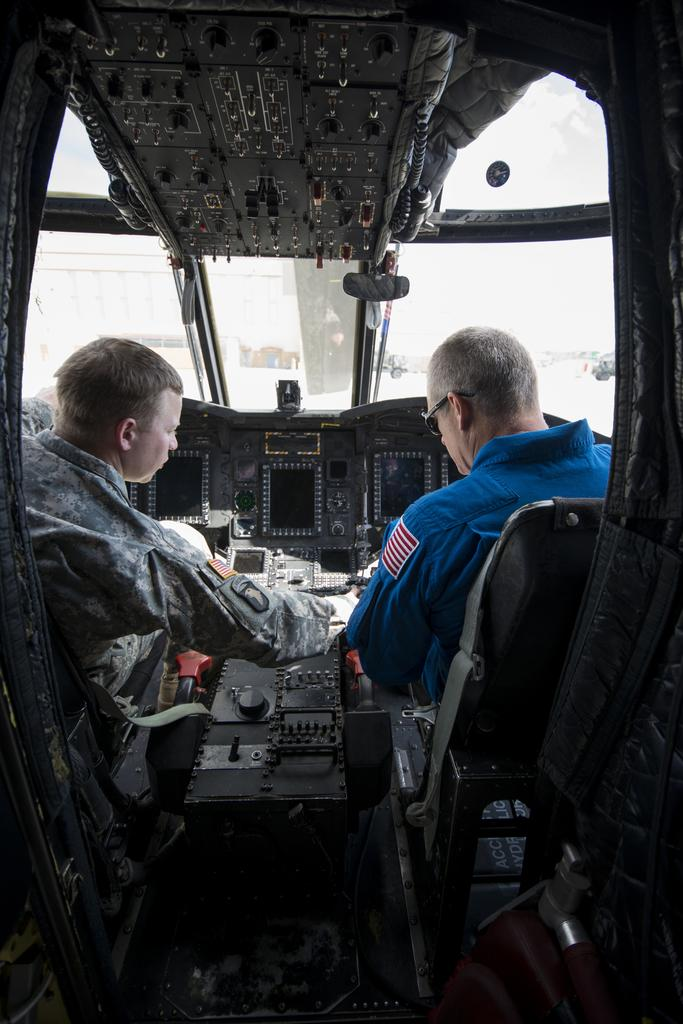What type of location is depicted in the image? The image shows the inside view of an aircraft. Are there any people present in the image? Yes, there are people in the image. What type of furniture is visible in the image? There are chairs in the image. Can you describe any other objects visible in the image? There are other objects visible in the image, but their specific details are not mentioned in the provided facts. What type of flag is being waved by the ghost in the image? There is no ghost or flag present in the image. Can you describe the cow that is sitting on the chair in the image? There is no cow present in the image. 